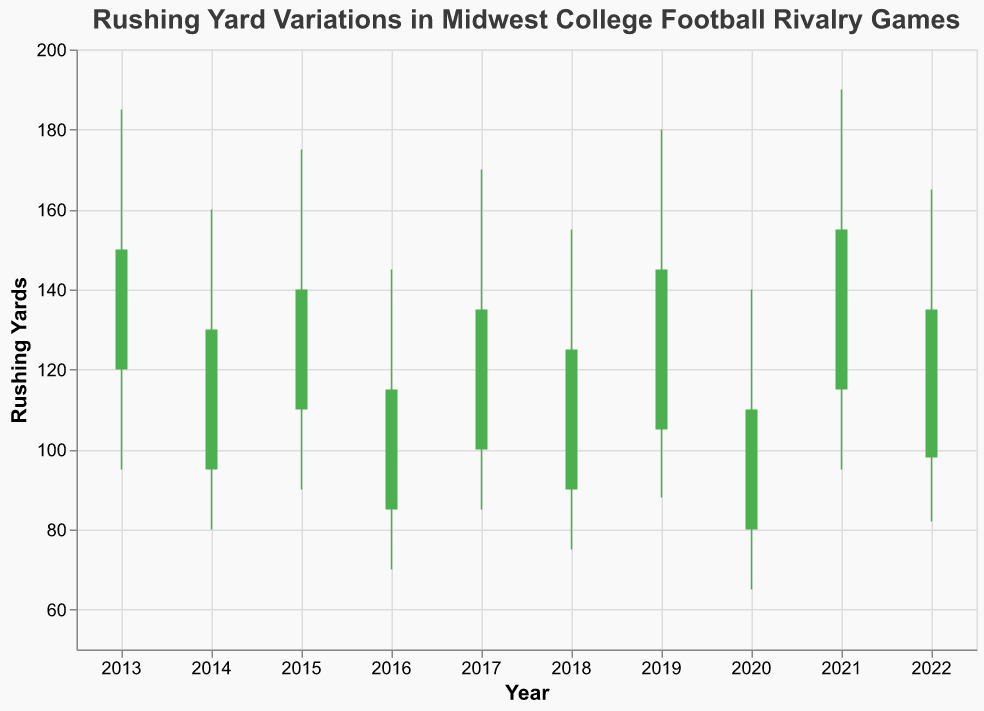What is the highest rushing yard recorded in the data? The highest rushing yard recorded is shown in the "High" field for each year. Scanning through the data, the highest value is 190 by Purdue in 2021.
Answer: 190 Which team's running backs had the lowest opening rushing yards over the past decade? The opening rushing yards are given in the "Open" field for each year. The lowest opening value is 80, recorded by Northwestern in 2020.
Answer: Northwestern Did Penn State's closing rushing yards increase or decrease from the opening in their rivalry game? For Penn State in 2019, the "Open" value is 105, and the "Close" value is 145. The closing value is higher than the opening value. Therefore, the closing rushing yards increased.
Answer: Increase Which rivalry game had the largest range of rushing yards recorded in a single year? The range can be calculated by subtracting the "Low" value from the "High" value for each year. The largest range is 95, for Purdue in 2021 (190 - 95).
Answer: Purdue vs Indiana Was there any year where the team closed with fewer rushing yards than they opened? If the "Close" value is less than the "Open" value, then the team closed with fewer rushing yards. Scanning through the data, this happened in 2016 with Iowa (115 < 85) and Michigan State in 2018 (125 < 90).
Answer: Yes, Iowa in 2016 and Michigan State in 2018 How many teams ended their games with higher rushing yards than they started with? Counting the instances where the "Close" value is greater than the "Open" value. The teams are Ohio State in 2013, Michigan in 2015, Penn State in 2019, Purdue in 2021, and Minnesota in 2022. Therefore, 5 teams ended with higher rushing yards.
Answer: 5 What is the average highest rushing yard recorded over the decade? To calculate the average, sum the "High" values and divide by the number of entries: (185 + 160 + 175 + 145 + 170 + 155 + 180 + 140 + 190 + 165) / 10 = 1745 / 10 = 174.5
Answer: 174.5 Which team had the smallest difference between their highest and lowest rushing yards in their rivalry game? The difference is calculated by subtracting the "Low" value from the "High" value. The smallest difference is 70 yards by Iowa in 2016 (145 - 70).
Answer: Iowa in 2016 What is the sum of the "Open" and "Close" values for Minnesota in 2022? Adding the "Open" value (98) and the "Close" value (135) for Minnesota in 2022 results in 98 + 135 = 233.
Answer: 233 